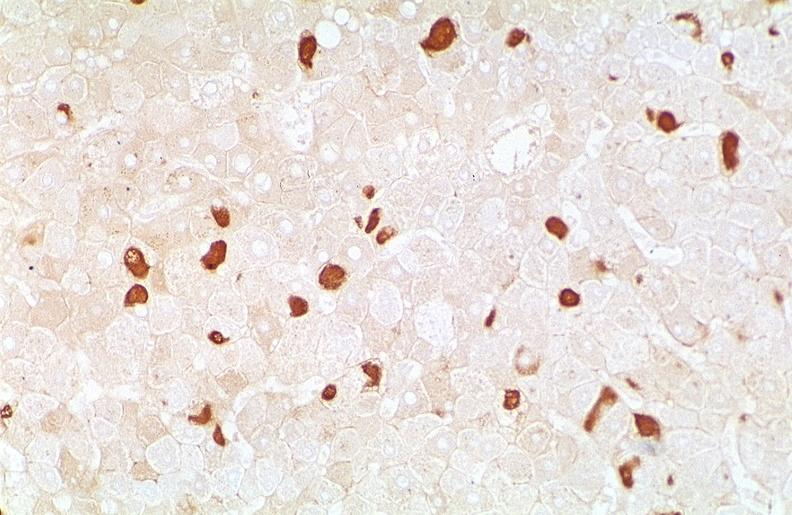what is present?
Answer the question using a single word or phrase. Liver 